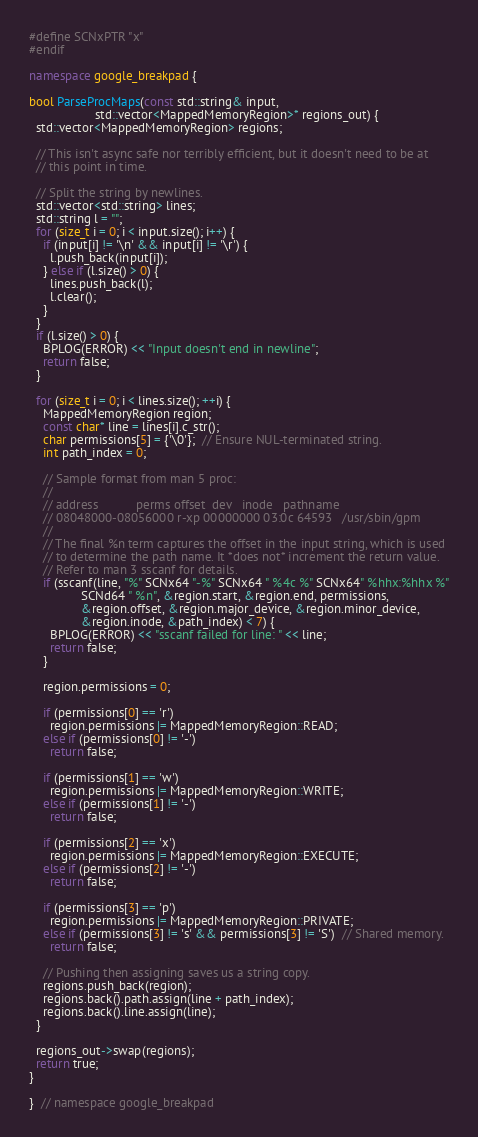<code> <loc_0><loc_0><loc_500><loc_500><_C++_>#define SCNxPTR "x"
#endif

namespace google_breakpad {

bool ParseProcMaps(const std::string& input,
                   std::vector<MappedMemoryRegion>* regions_out) {
  std::vector<MappedMemoryRegion> regions;

  // This isn't async safe nor terribly efficient, but it doesn't need to be at
  // this point in time.

  // Split the string by newlines.
  std::vector<std::string> lines;
  std::string l = "";
  for (size_t i = 0; i < input.size(); i++) {
    if (input[i] != '\n' && input[i] != '\r') {
      l.push_back(input[i]);
    } else if (l.size() > 0) {
      lines.push_back(l);
      l.clear();
    }
  }
  if (l.size() > 0) {
    BPLOG(ERROR) << "Input doesn't end in newline";
    return false;
  }

  for (size_t i = 0; i < lines.size(); ++i) {
    MappedMemoryRegion region;
    const char* line = lines[i].c_str();
    char permissions[5] = {'\0'};  // Ensure NUL-terminated string.
    int path_index = 0;

    // Sample format from man 5 proc:
    //
    // address           perms offset  dev   inode   pathname
    // 08048000-08056000 r-xp 00000000 03:0c 64593   /usr/sbin/gpm
    //
    // The final %n term captures the offset in the input string, which is used
    // to determine the path name. It *does not* increment the return value.
    // Refer to man 3 sscanf for details.
    if (sscanf(line, "%" SCNx64 "-%" SCNx64 " %4c %" SCNx64" %hhx:%hhx %"
               SCNd64 " %n", &region.start, &region.end, permissions,
               &region.offset, &region.major_device, &region.minor_device,
               &region.inode, &path_index) < 7) {
      BPLOG(ERROR) << "sscanf failed for line: " << line;
      return false;
    }

    region.permissions = 0;

    if (permissions[0] == 'r')
      region.permissions |= MappedMemoryRegion::READ;
    else if (permissions[0] != '-')
      return false;

    if (permissions[1] == 'w')
      region.permissions |= MappedMemoryRegion::WRITE;
    else if (permissions[1] != '-')
      return false;

    if (permissions[2] == 'x')
      region.permissions |= MappedMemoryRegion::EXECUTE;
    else if (permissions[2] != '-')
      return false;

    if (permissions[3] == 'p')
      region.permissions |= MappedMemoryRegion::PRIVATE;
    else if (permissions[3] != 's' && permissions[3] != 'S')  // Shared memory.
      return false;

    // Pushing then assigning saves us a string copy.
    regions.push_back(region);
    regions.back().path.assign(line + path_index);
    regions.back().line.assign(line);
  }

  regions_out->swap(regions);
  return true;
}

}  // namespace google_breakpad
</code> 